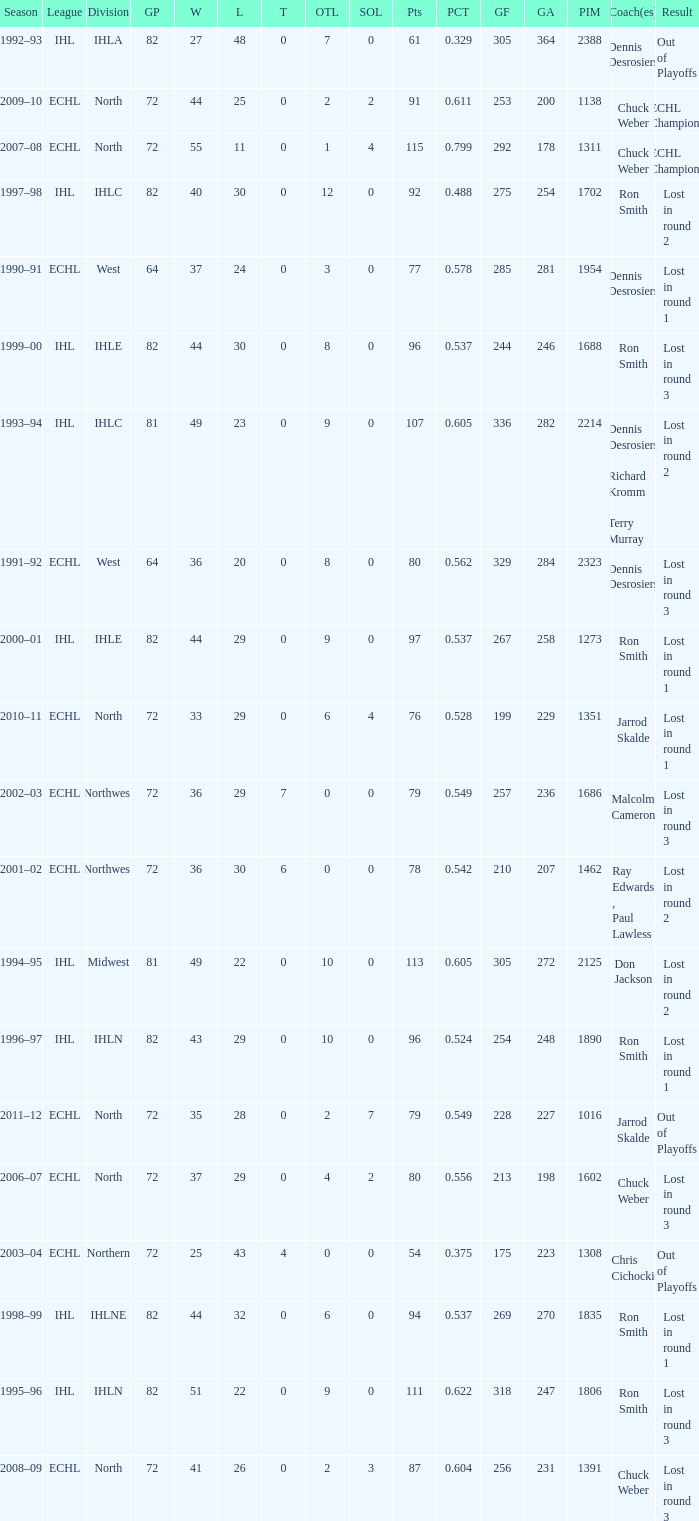What was the maximum OTL if L is 28? 2.0. 